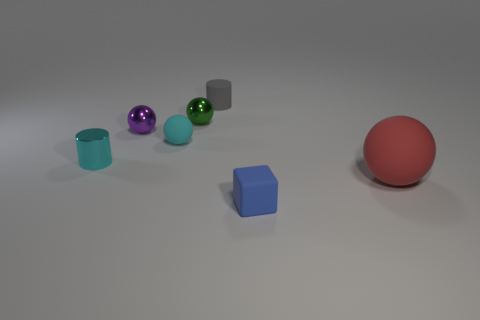There is a thing that is in front of the red matte sphere; is its shape the same as the object behind the tiny green object?
Make the answer very short. No. How many things are big red matte blocks or things that are to the left of the blue matte thing?
Ensure brevity in your answer.  5. There is a tiny object that is the same color as the small shiny cylinder; what shape is it?
Provide a succinct answer. Sphere. How many other matte objects have the same size as the blue rubber thing?
Make the answer very short. 2. What number of cyan things are rubber spheres or small rubber blocks?
Your response must be concise. 1. The small thing that is in front of the small cyan shiny cylinder that is on the left side of the small cyan matte ball is what shape?
Ensure brevity in your answer.  Cube. What is the shape of the purple object that is the same size as the metal cylinder?
Ensure brevity in your answer.  Sphere. Are there any rubber objects of the same color as the matte cube?
Offer a very short reply. No. Are there an equal number of blue matte cubes that are behind the purple object and cyan matte things that are to the right of the red ball?
Your response must be concise. Yes. Do the green thing and the thing to the right of the small blue cube have the same shape?
Your answer should be compact. Yes. 